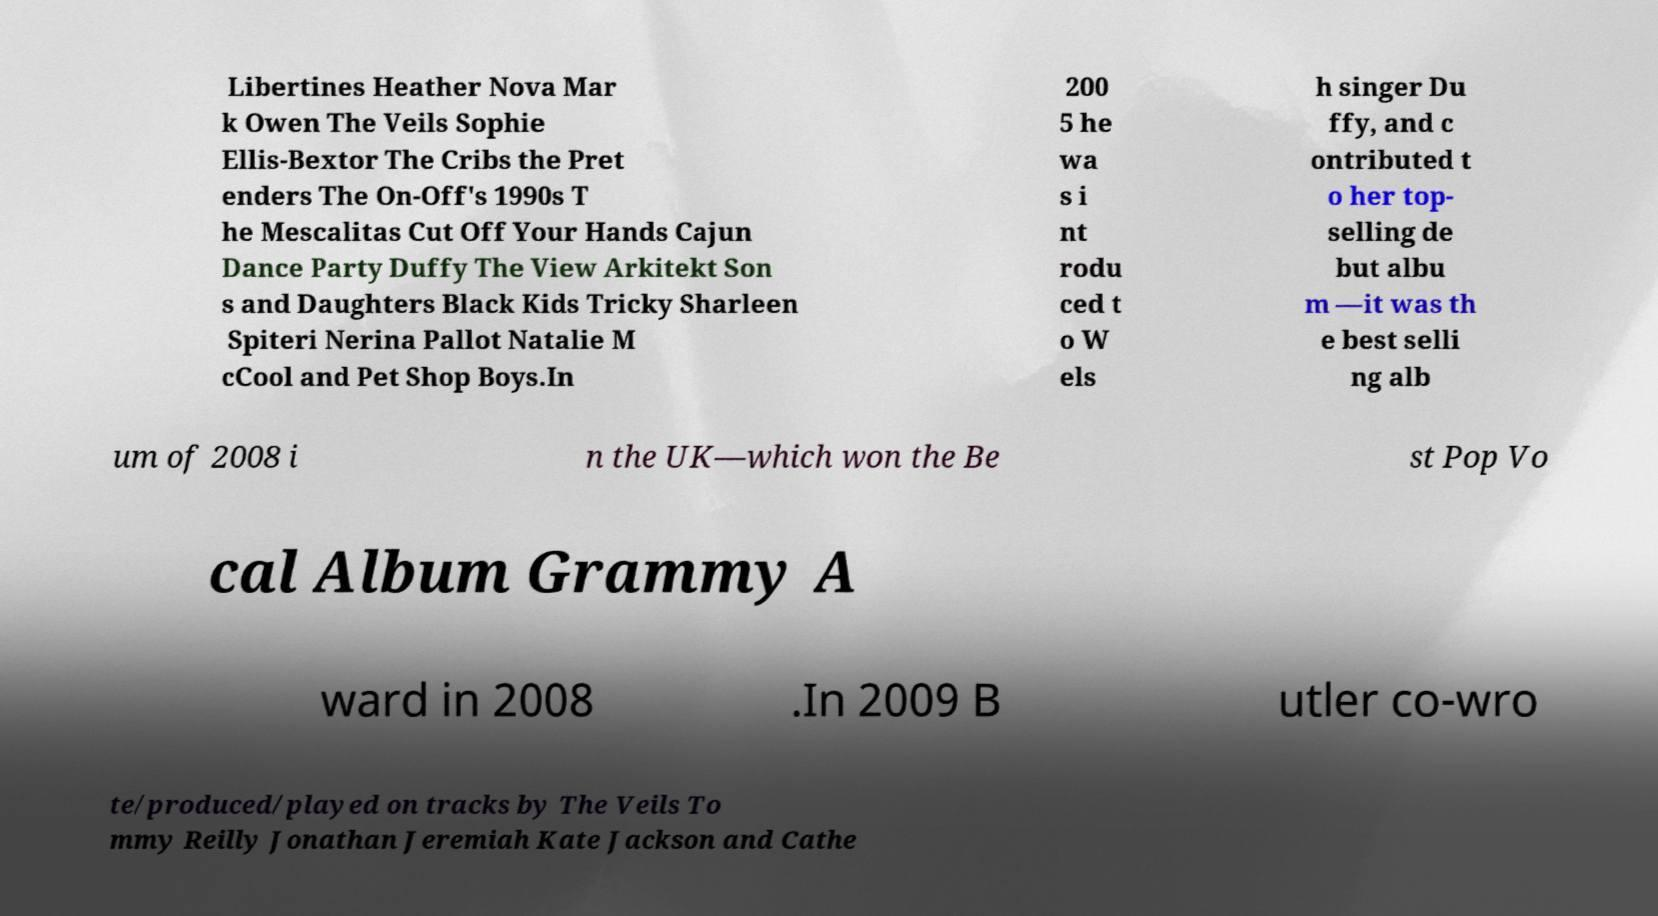Please read and relay the text visible in this image. What does it say? Libertines Heather Nova Mar k Owen The Veils Sophie Ellis-Bextor The Cribs the Pret enders The On-Off's 1990s T he Mescalitas Cut Off Your Hands Cajun Dance Party Duffy The View Arkitekt Son s and Daughters Black Kids Tricky Sharleen Spiteri Nerina Pallot Natalie M cCool and Pet Shop Boys.In 200 5 he wa s i nt rodu ced t o W els h singer Du ffy, and c ontributed t o her top- selling de but albu m —it was th e best selli ng alb um of 2008 i n the UK—which won the Be st Pop Vo cal Album Grammy A ward in 2008 .In 2009 B utler co-wro te/produced/played on tracks by The Veils To mmy Reilly Jonathan Jeremiah Kate Jackson and Cathe 